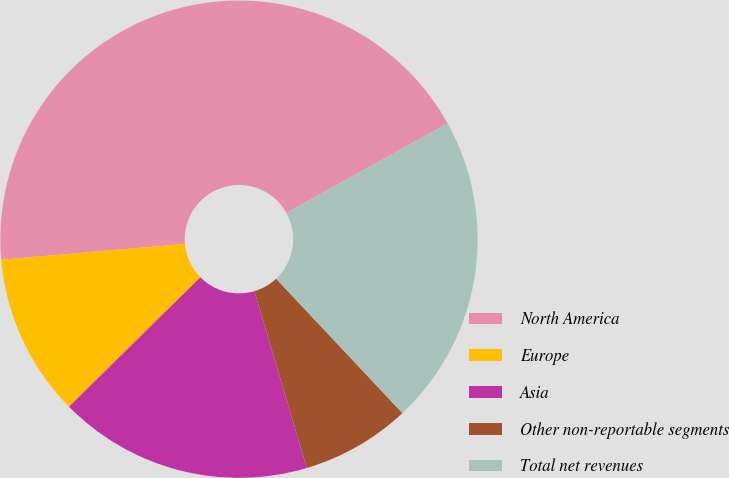Convert chart. <chart><loc_0><loc_0><loc_500><loc_500><pie_chart><fcel>North America<fcel>Europe<fcel>Asia<fcel>Other non-reportable segments<fcel>Total net revenues<nl><fcel>43.31%<fcel>11.01%<fcel>17.21%<fcel>7.42%<fcel>21.06%<nl></chart> 